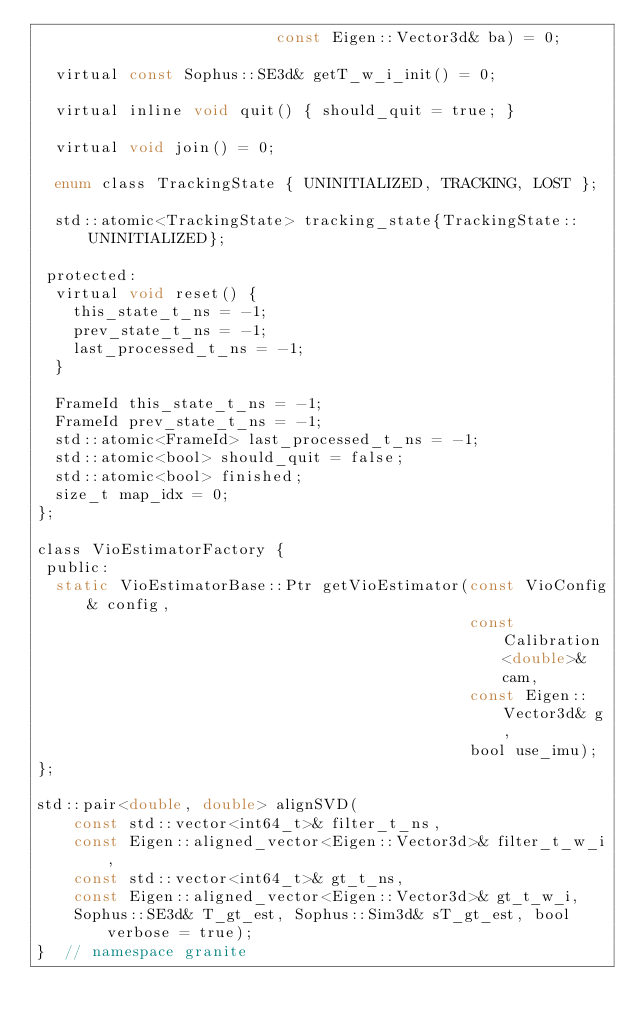Convert code to text. <code><loc_0><loc_0><loc_500><loc_500><_C_>                          const Eigen::Vector3d& ba) = 0;

  virtual const Sophus::SE3d& getT_w_i_init() = 0;

  virtual inline void quit() { should_quit = true; }

  virtual void join() = 0;

  enum class TrackingState { UNINITIALIZED, TRACKING, LOST };

  std::atomic<TrackingState> tracking_state{TrackingState::UNINITIALIZED};

 protected:
  virtual void reset() {
    this_state_t_ns = -1;
    prev_state_t_ns = -1;
    last_processed_t_ns = -1;
  }

  FrameId this_state_t_ns = -1;
  FrameId prev_state_t_ns = -1;
  std::atomic<FrameId> last_processed_t_ns = -1;
  std::atomic<bool> should_quit = false;
  std::atomic<bool> finished;
  size_t map_idx = 0;
};

class VioEstimatorFactory {
 public:
  static VioEstimatorBase::Ptr getVioEstimator(const VioConfig& config,
                                               const Calibration<double>& cam,
                                               const Eigen::Vector3d& g,
                                               bool use_imu);
};

std::pair<double, double> alignSVD(
    const std::vector<int64_t>& filter_t_ns,
    const Eigen::aligned_vector<Eigen::Vector3d>& filter_t_w_i,
    const std::vector<int64_t>& gt_t_ns,
    const Eigen::aligned_vector<Eigen::Vector3d>& gt_t_w_i,
    Sophus::SE3d& T_gt_est, Sophus::Sim3d& sT_gt_est, bool verbose = true);
}  // namespace granite
</code> 